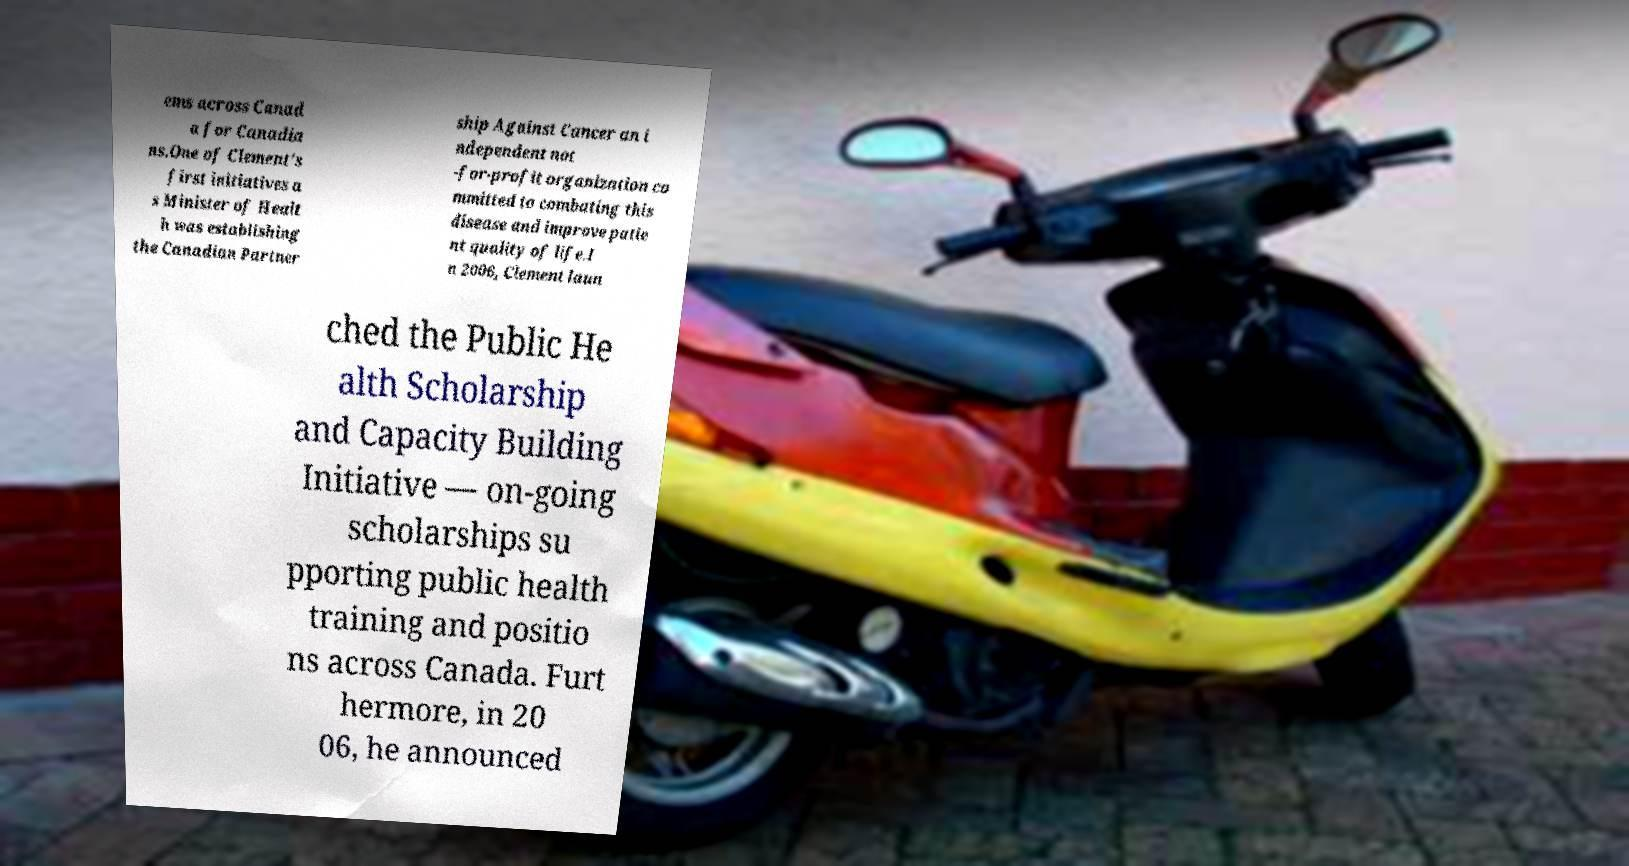Can you read and provide the text displayed in the image?This photo seems to have some interesting text. Can you extract and type it out for me? ems across Canad a for Canadia ns.One of Clement's first initiatives a s Minister of Healt h was establishing the Canadian Partner ship Against Cancer an i ndependent not -for-profit organization co mmitted to combating this disease and improve patie nt quality of life.I n 2006, Clement laun ched the Public He alth Scholarship and Capacity Building Initiative — on-going scholarships su pporting public health training and positio ns across Canada. Furt hermore, in 20 06, he announced 